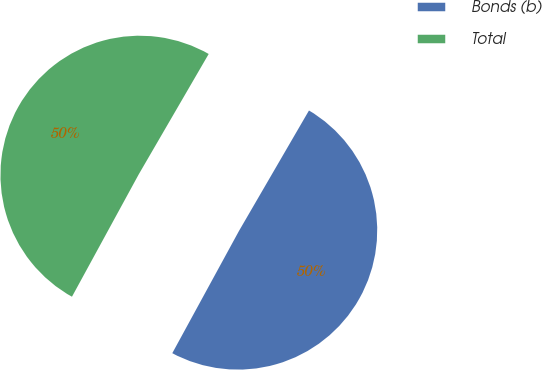<chart> <loc_0><loc_0><loc_500><loc_500><pie_chart><fcel>Bonds (b)<fcel>Total<nl><fcel>49.57%<fcel>50.43%<nl></chart> 